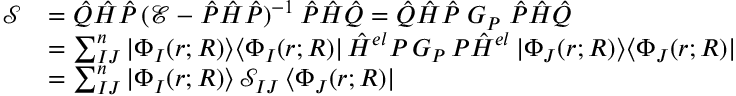<formula> <loc_0><loc_0><loc_500><loc_500>\begin{array} { r l } { \mathcal { S } } & { = \hat { Q } \hat { H } \hat { P } \, ( \mathcal { E } - \hat { P } \hat { H } \hat { P } ) ^ { - 1 } \, \hat { P } \hat { H } \hat { Q } = \hat { Q } \hat { H } \hat { P } \, G _ { P } \, \hat { P } \hat { H } \hat { Q } } \\ & { = \sum _ { I J } ^ { n } | \Phi _ { I } ( r ; R ) \rangle \langle \Phi _ { I } ( r ; R ) | \, \hat { H } ^ { e l } P \, G _ { P } \, P \hat { H } ^ { e l } \, | \Phi _ { J } ( r ; R ) \rangle \langle \Phi _ { J } ( r ; R ) | } \\ & { = \sum _ { I J } ^ { n } | \Phi _ { I } ( r ; R ) \rangle \, \mathcal { S } _ { I J } \, \langle \Phi _ { J } ( r ; R ) | } \end{array}</formula> 